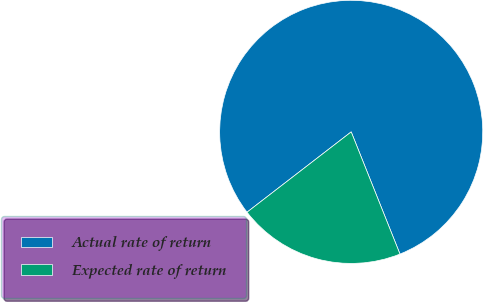Convert chart. <chart><loc_0><loc_0><loc_500><loc_500><pie_chart><fcel>Actual rate of return<fcel>Expected rate of return<nl><fcel>79.41%<fcel>20.59%<nl></chart> 